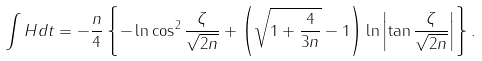<formula> <loc_0><loc_0><loc_500><loc_500>\int H d t = - \frac { n } { 4 } \left \{ - \ln \cos ^ { 2 } \frac { \zeta } { \sqrt { 2 n } } + \left ( \sqrt { 1 + \frac { 4 } { 3 n } } - 1 \right ) \ln \left | \tan \frac { \zeta } { \sqrt { 2 n } } \right | \right \} .</formula> 